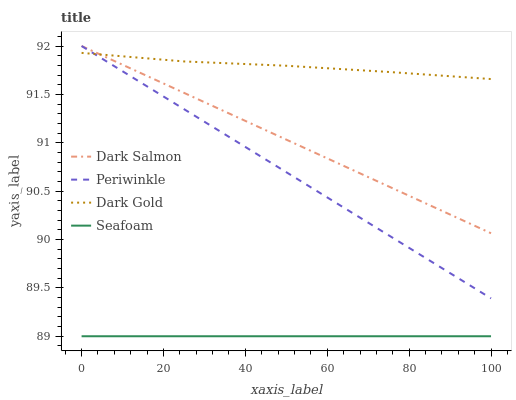Does Periwinkle have the minimum area under the curve?
Answer yes or no. No. Does Periwinkle have the maximum area under the curve?
Answer yes or no. No. Is Periwinkle the smoothest?
Answer yes or no. No. Is Periwinkle the roughest?
Answer yes or no. No. Does Periwinkle have the lowest value?
Answer yes or no. No. Does Dark Gold have the highest value?
Answer yes or no. No. Is Seafoam less than Dark Gold?
Answer yes or no. Yes. Is Dark Salmon greater than Seafoam?
Answer yes or no. Yes. Does Seafoam intersect Dark Gold?
Answer yes or no. No. 